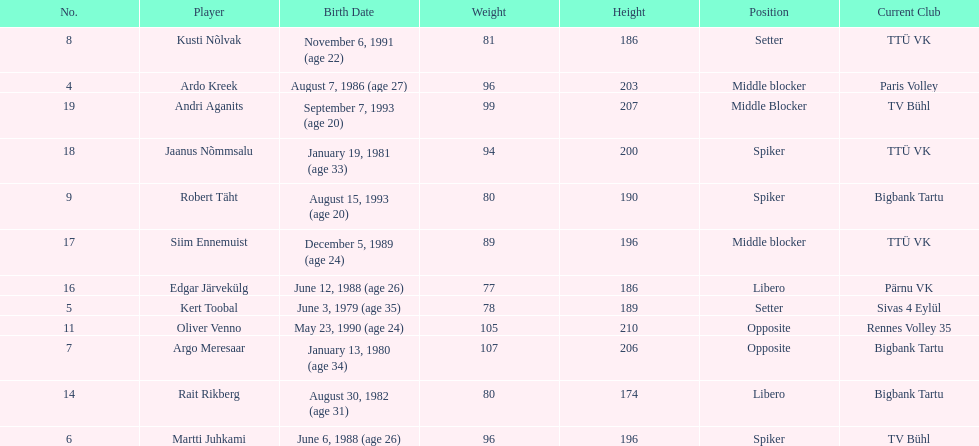How many players are middle blockers? 3. 